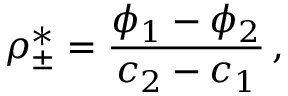Convert formula to latex. <formula><loc_0><loc_0><loc_500><loc_500>\rho _ { \pm } ^ { * } = \frac { \phi _ { 1 } - \phi _ { 2 } } { c _ { 2 } - c _ { 1 } } \, ,</formula> 